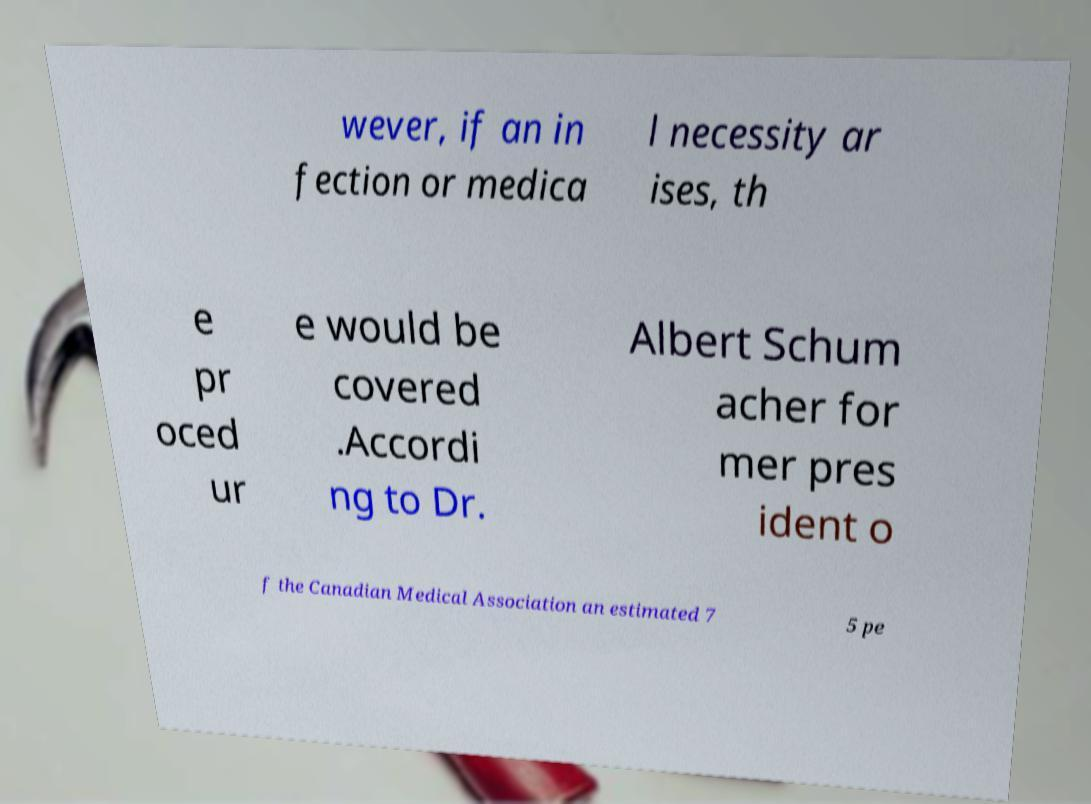I need the written content from this picture converted into text. Can you do that? wever, if an in fection or medica l necessity ar ises, th e pr oced ur e would be covered .Accordi ng to Dr. Albert Schum acher for mer pres ident o f the Canadian Medical Association an estimated 7 5 pe 